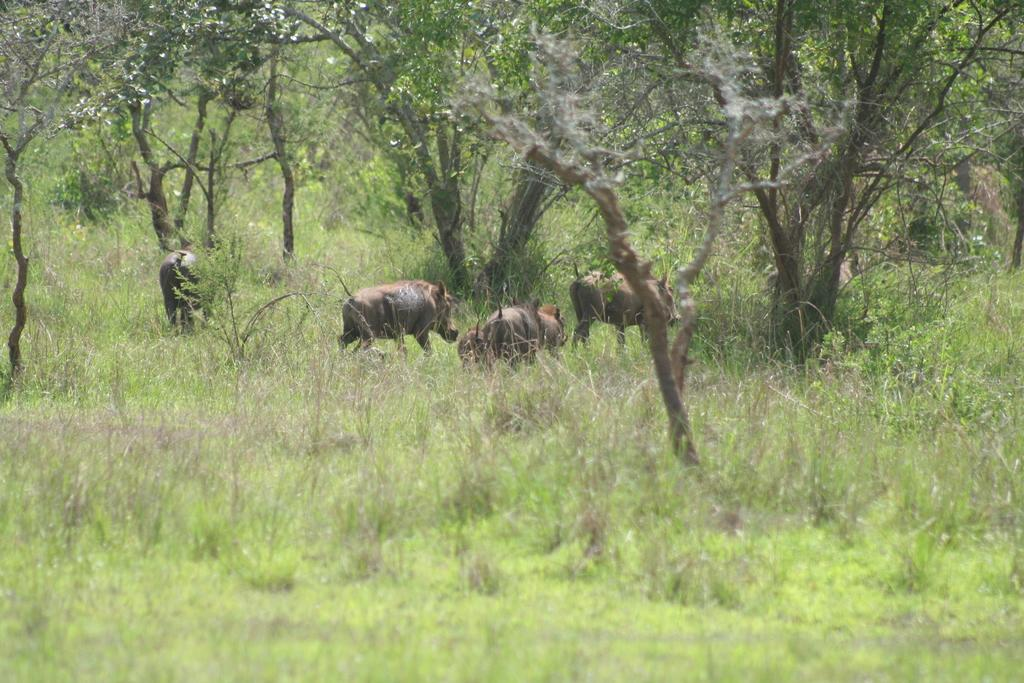What type of vegetation is at the bottom of the image? There is grass at the bottom of the image. What can be seen in the middle of the image? There are animals in the middle of the image. What is located behind the animals in the image? There are trees behind the animals in the animals. Can you tell me where the locket is located in the image? There is no locket present in the image. Is there a crown visible on any of the animals in the image? There is no crown visible on any of the animals in the image. 